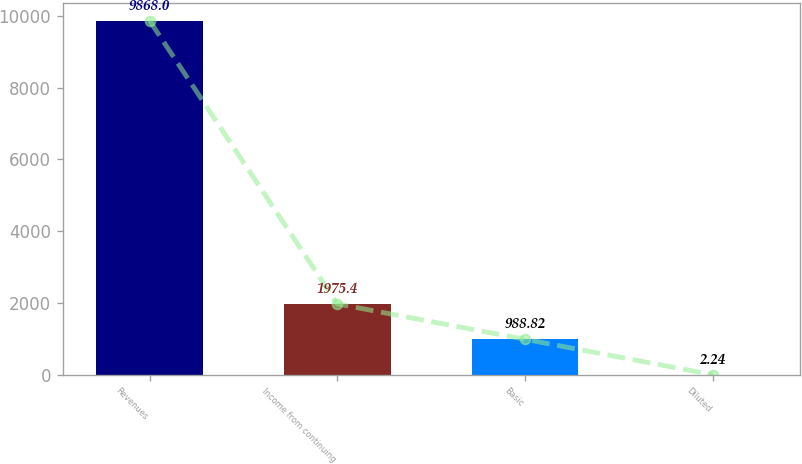Convert chart to OTSL. <chart><loc_0><loc_0><loc_500><loc_500><bar_chart><fcel>Revenues<fcel>Income from continuing<fcel>Basic<fcel>Diluted<nl><fcel>9868<fcel>1975.4<fcel>988.82<fcel>2.24<nl></chart> 